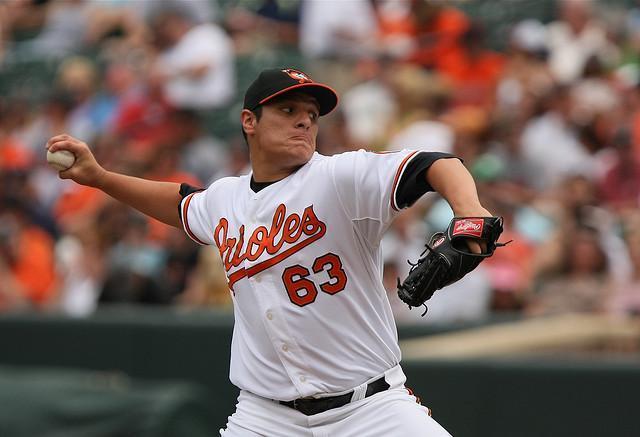How many people are there?
Give a very brief answer. 11. How many ingredients are on the pizza on the far left?
Give a very brief answer. 0. 